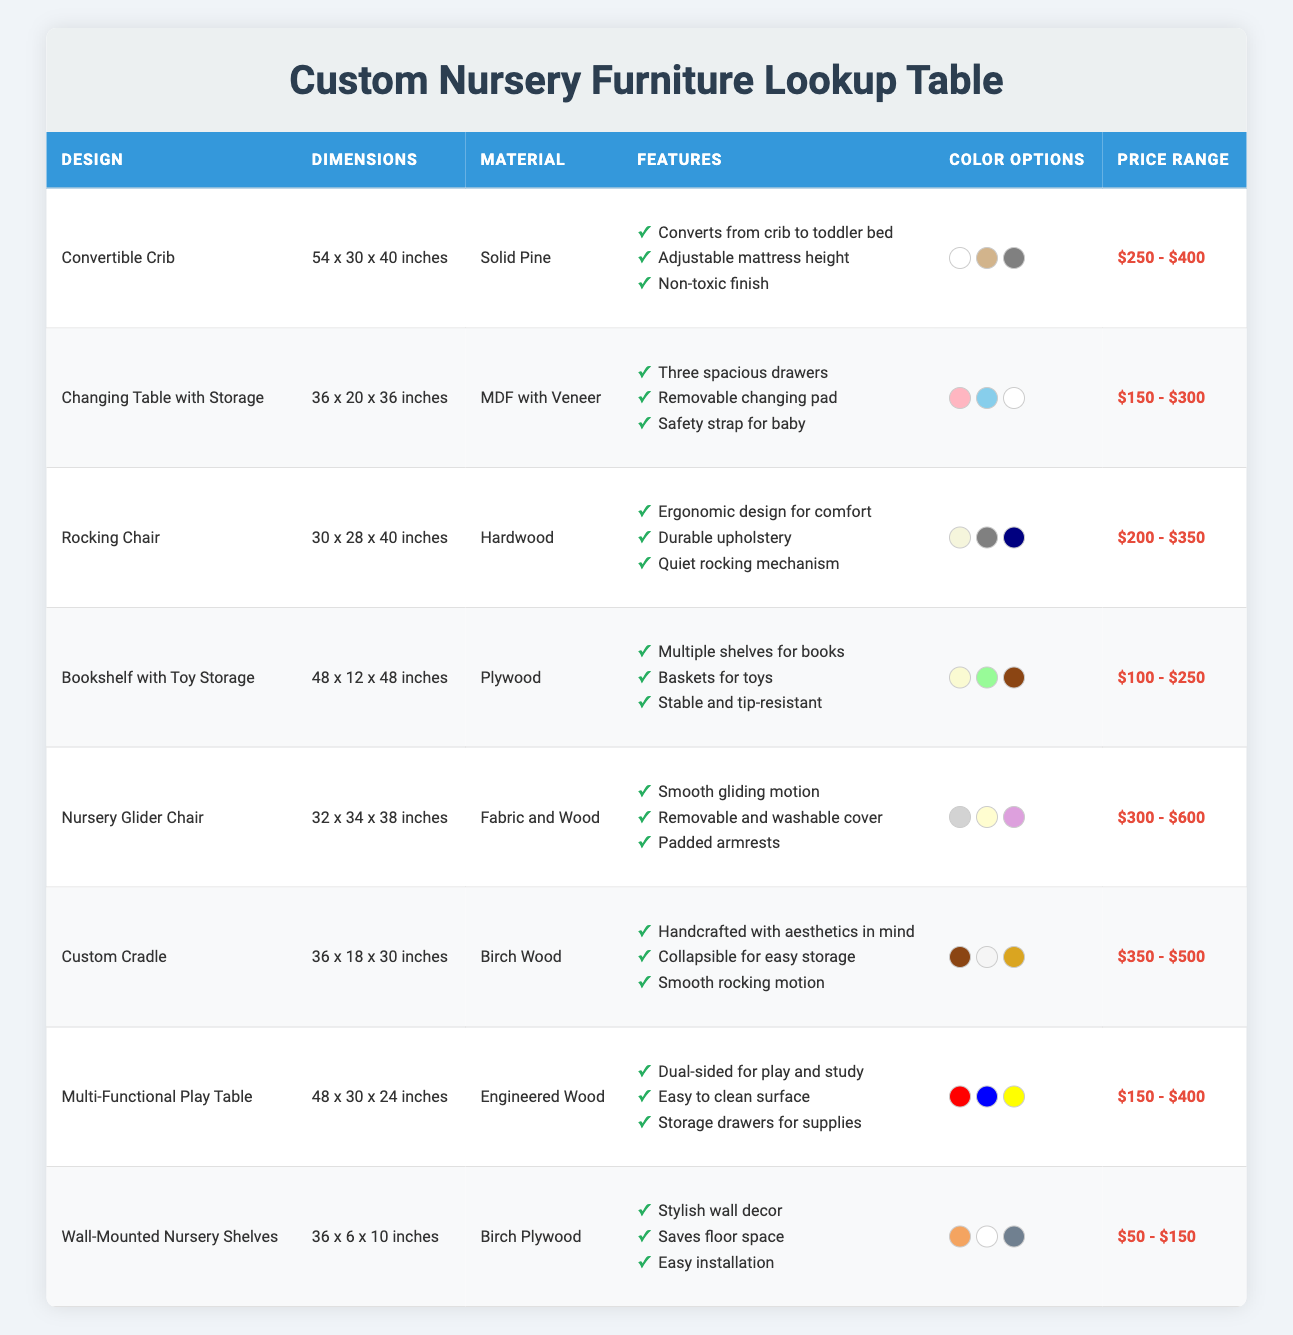What is the price range of the Convertible Crib? The price range can be found in the corresponding row for the Convertible Crib design. It states that the price range is "$250 - $400".
Answer: $250 - $400 How many color options are available for the Changing Table with Storage? By looking at the Changing Table with Storage row, it lists three available color options: Soft Pink, Sky Blue, and Classic White. Therefore, the number of color options is three.
Answer: 3 Does the Nursery Glider Chair have a removable cover? The features listed for the Nursery Glider Chair include "Removable and washable cover", indicating that it does have this feature. Therefore, the answer is Yes.
Answer: Yes Which furniture design has the largest dimensions? By comparing all the dimensions listed in the table, the Bookshelf with Toy Storage has the largest dimensions at 48 x 12 x 48 inches. The other designs have smaller dimensions when assessed.
Answer: Bookshelf with Toy Storage What is the average price range of all furniture designs in the table? The price ranges for comparison are: $250 - $400, $150 - $300, $200 - $350, $100 - $250, $300 - $600, $350 - $500, $150 - $400, and $50 - $150. The average can be approximately calculated by summing the midpoints of each range and dividing by the number of designs: (325 + 225 + 275 + 175 + 450 + 425 + 275 + 100) / 8 = 269.375.
Answer: Approximately $269.38 Is the material of the Custom Cradle Birch Wood? According to the table, the Custom Cradle row states that its material is "Birch Wood." Therefore, the answer is Yes.
Answer: Yes What features are unique to the Rocking Chair compared to the Convertible Crib? The Rocking Chair has unique features that are not found in the Convertible Crib. These features include "Ergonomic design for comfort", "Durable upholstery", and "Quiet rocking mechanism". The Convertible Crib does not list these features.
Answer: Three unique features Which color option is available for the Multi-Functional Play Table? The available color options for the Multi-Functional Play Table, as listed in its row, include Bright Red, Cool Blue, and Sunny Yellow. Therefore, it has three color options.
Answer: Bright Red, Cool Blue, Sunny Yellow How many designs have a price range of $300 or more? Assessing the price ranges of all designs in the table, the following have price ranges of $300 or more: Nursery Glider Chair, Custom Cradle, and the Convertible Crib. Thus, a total of three designs meet this criterion.
Answer: 3 Is the Wall-Mounted Nursery Shelves design made of Solid Pine? The material for the Wall-Mounted Nursery Shelves design is listed as "Birch Plywood," indicating that it is not made of Solid Pine. Thus, the answer is No.
Answer: No 